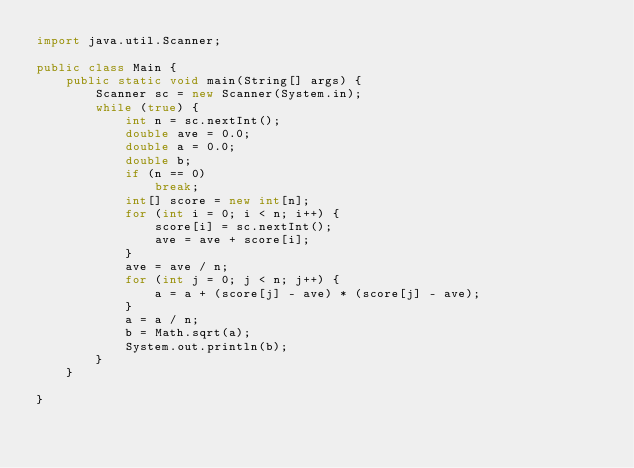<code> <loc_0><loc_0><loc_500><loc_500><_Java_>import java.util.Scanner;

public class Main {
	public static void main(String[] args) {
		Scanner sc = new Scanner(System.in);
		while (true) {
			int n = sc.nextInt();
			double ave = 0.0;
			double a = 0.0;
			double b;
			if (n == 0)
				break;
			int[] score = new int[n];
			for (int i = 0; i < n; i++) {
				score[i] = sc.nextInt();
				ave = ave + score[i];
			}
			ave = ave / n;
			for (int j = 0; j < n; j++) {
				a = a + (score[j] - ave) * (score[j] - ave);
			}
			a = a / n;
			b = Math.sqrt(a);
			System.out.println(b);
		}
	}

}
</code> 